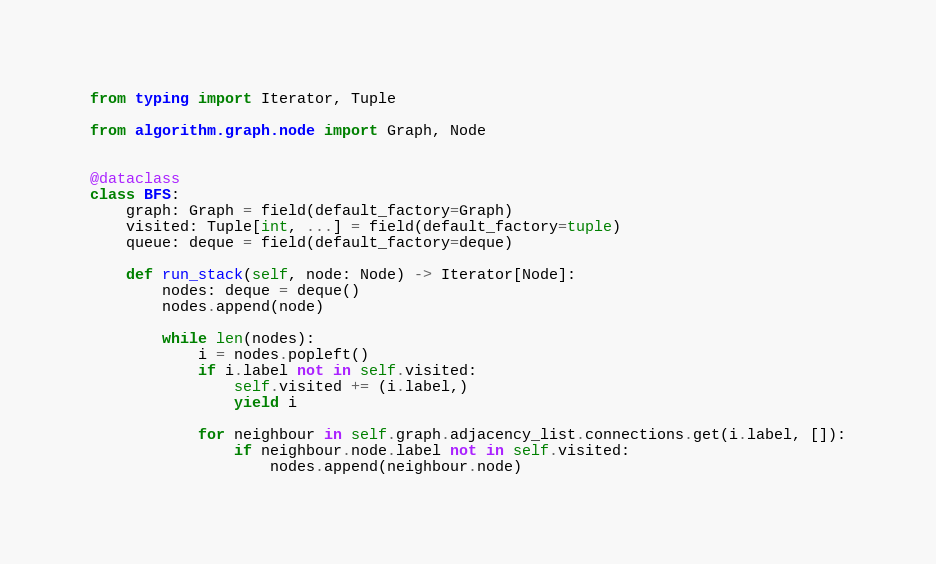<code> <loc_0><loc_0><loc_500><loc_500><_Python_>from typing import Iterator, Tuple

from algorithm.graph.node import Graph, Node


@dataclass
class BFS:
    graph: Graph = field(default_factory=Graph)
    visited: Tuple[int, ...] = field(default_factory=tuple)
    queue: deque = field(default_factory=deque)

    def run_stack(self, node: Node) -> Iterator[Node]:
        nodes: deque = deque()
        nodes.append(node)

        while len(nodes):
            i = nodes.popleft()
            if i.label not in self.visited:
                self.visited += (i.label,)
                yield i

            for neighbour in self.graph.adjacency_list.connections.get(i.label, []):
                if neighbour.node.label not in self.visited:
                    nodes.append(neighbour.node)
</code> 